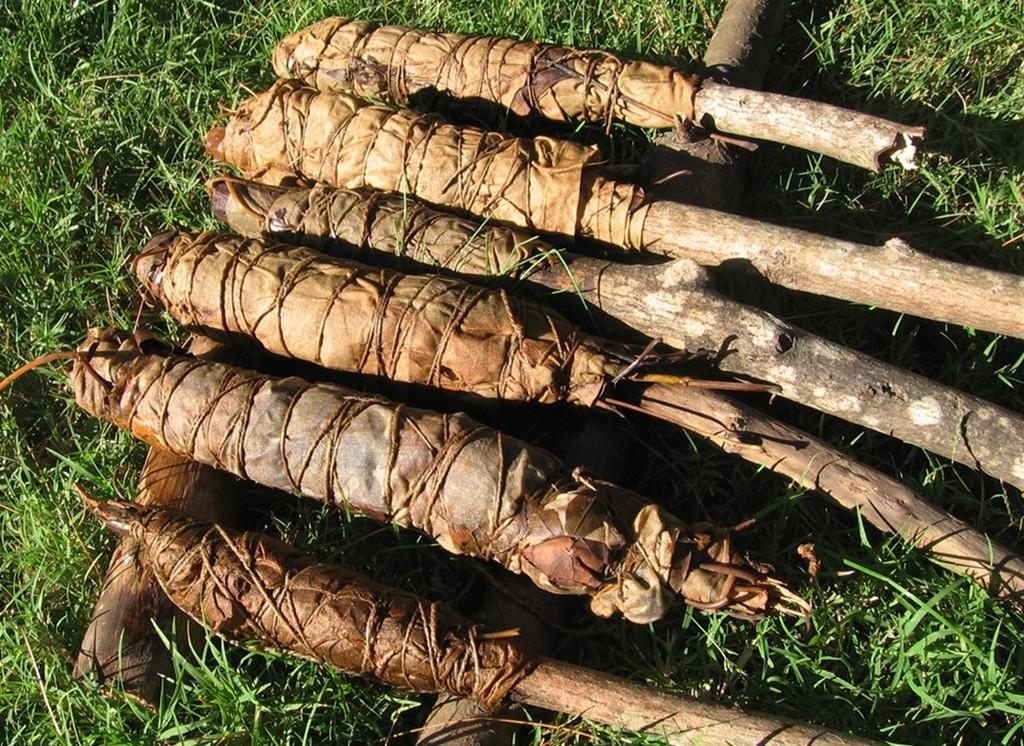What is in the foreground of the image? There are leaves in the foreground of the image. How are the leaves arranged or connected? The leaves are tied to wooden poles. What is the surface on which the wooden poles are placed? The wooden poles are on the grass. What type of disease can be seen affecting the leaves in the image? There is no indication of a disease affecting the leaves in the image; they appear to be tied to wooden poles. What tool is being used to draw on the leaves in the image? There is no tool or drawing activity present in the image; the leaves are simply tied to wooden poles. 